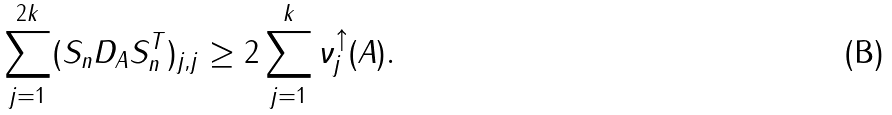Convert formula to latex. <formula><loc_0><loc_0><loc_500><loc_500>\sum _ { j = 1 } ^ { 2 k } ( S _ { n } D _ { A } S _ { n } ^ { T } ) _ { j , j } \geq 2 \sum _ { j = 1 } ^ { k } \nu _ { j } ^ { \uparrow } ( A ) .</formula> 